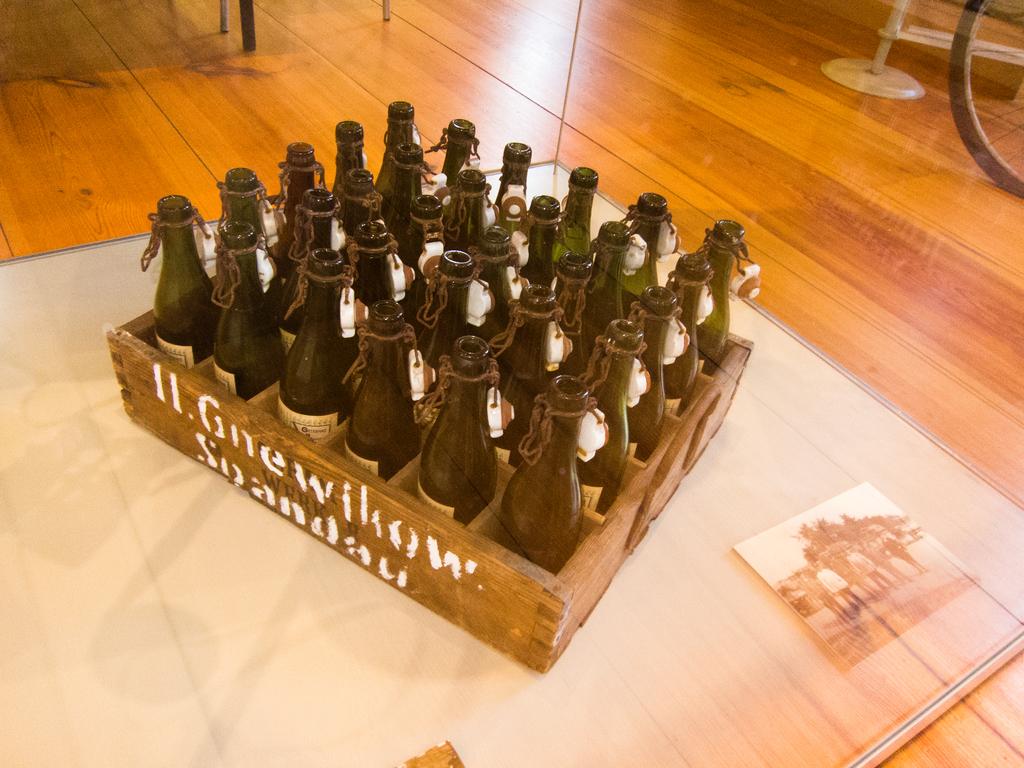What does the crate say?
Your answer should be compact. Image did not load. 